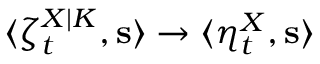<formula> <loc_0><loc_0><loc_500><loc_500>\langle \zeta _ { t } ^ { X | K } , s \rangle \to \langle \eta _ { t } ^ { X } , s \rangle</formula> 